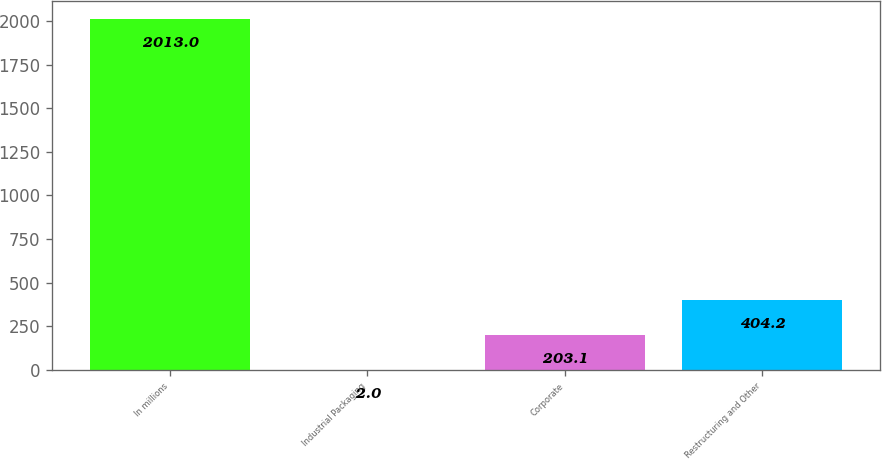Convert chart to OTSL. <chart><loc_0><loc_0><loc_500><loc_500><bar_chart><fcel>In millions<fcel>Industrial Packaging<fcel>Corporate<fcel>Restructuring and Other<nl><fcel>2013<fcel>2<fcel>203.1<fcel>404.2<nl></chart> 